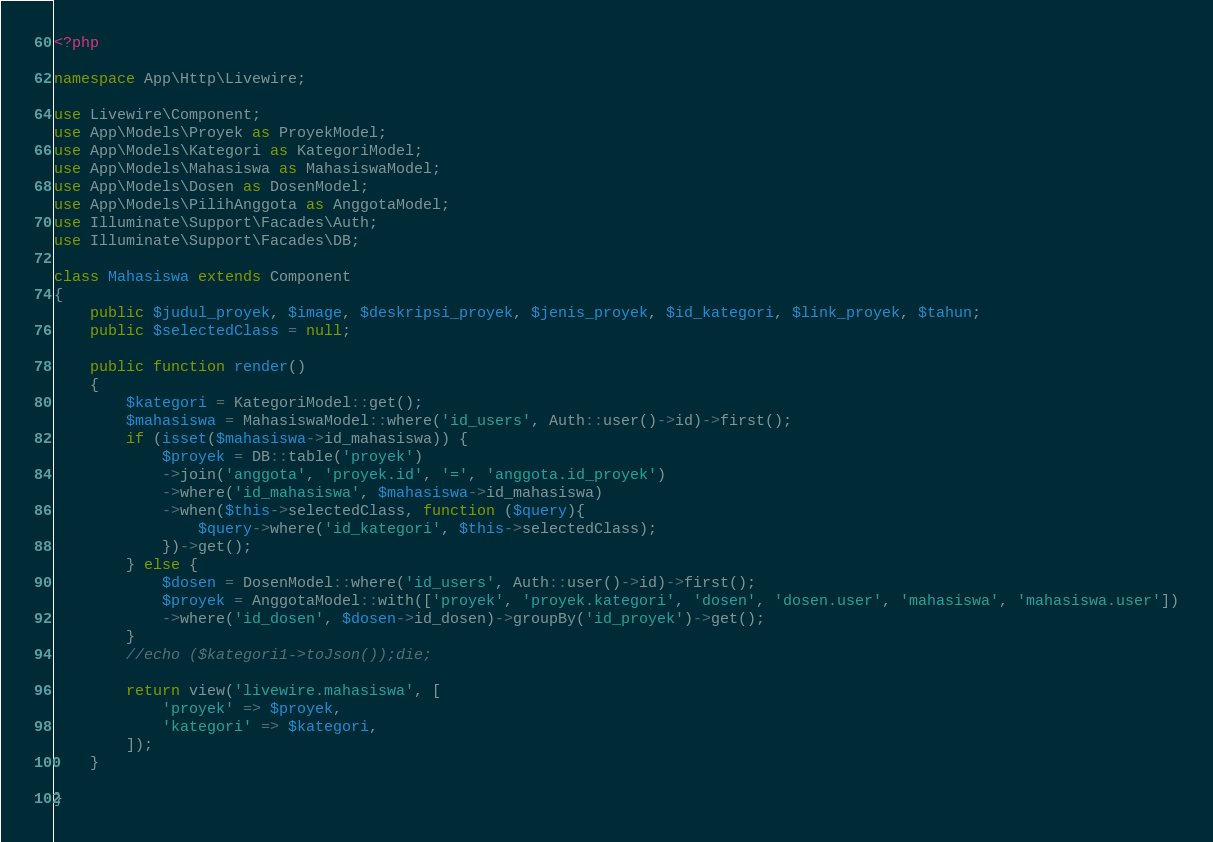<code> <loc_0><loc_0><loc_500><loc_500><_PHP_><?php

namespace App\Http\Livewire;

use Livewire\Component;
use App\Models\Proyek as ProyekModel;
use App\Models\Kategori as KategoriModel;
use App\Models\Mahasiswa as MahasiswaModel;
use App\Models\Dosen as DosenModel;
use App\Models\PilihAnggota as AnggotaModel;
use Illuminate\Support\Facades\Auth;
use Illuminate\Support\Facades\DB;

class Mahasiswa extends Component
{
    public $judul_proyek, $image, $deskripsi_proyek, $jenis_proyek, $id_kategori, $link_proyek, $tahun;
    public $selectedClass = null;

    public function render()
    {
        $kategori = KategoriModel::get();
        $mahasiswa = MahasiswaModel::where('id_users', Auth::user()->id)->first();
        if (isset($mahasiswa->id_mahasiswa)) {
            $proyek = DB::table('proyek')
            ->join('anggota', 'proyek.id', '=', 'anggota.id_proyek')
            ->where('id_mahasiswa', $mahasiswa->id_mahasiswa)
            ->when($this->selectedClass, function ($query){
                $query->where('id_kategori', $this->selectedClass);
            })->get();
        } else {
            $dosen = DosenModel::where('id_users', Auth::user()->id)->first();
            $proyek = AnggotaModel::with(['proyek', 'proyek.kategori', 'dosen', 'dosen.user', 'mahasiswa', 'mahasiswa.user'])
            ->where('id_dosen', $dosen->id_dosen)->groupBy('id_proyek')->get();
        }
        //echo ($kategori1->toJson());die;
        
        return view('livewire.mahasiswa', [
            'proyek' => $proyek,
            'kategori' => $kategori,
        ]);
    }

}
</code> 